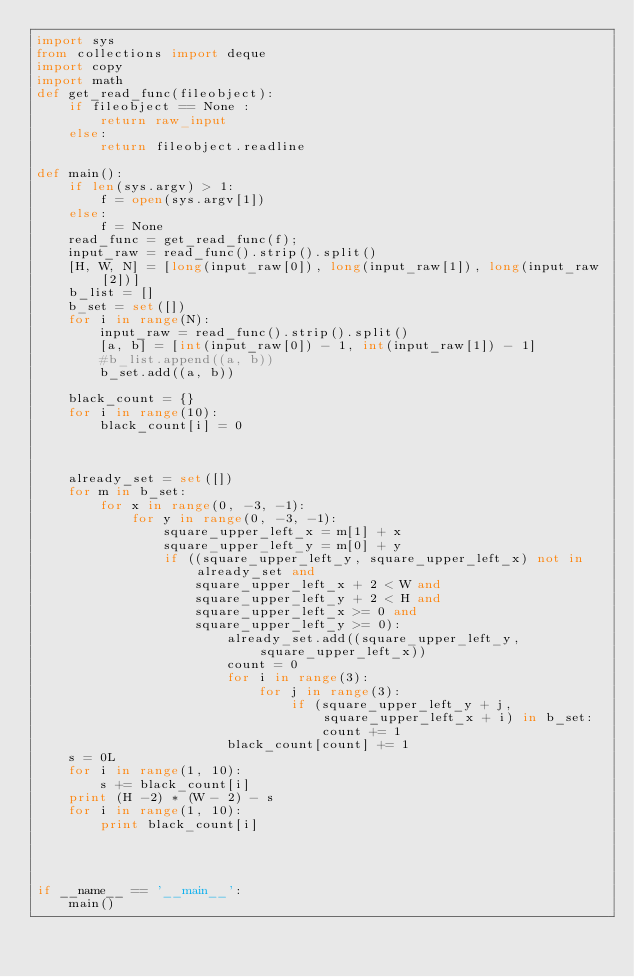<code> <loc_0><loc_0><loc_500><loc_500><_Python_>import sys
from collections import deque
import copy
import math
def get_read_func(fileobject):
    if fileobject == None :
        return raw_input
    else:
        return fileobject.readline

def main():
    if len(sys.argv) > 1:
        f = open(sys.argv[1])
    else:
        f = None
    read_func = get_read_func(f);
    input_raw = read_func().strip().split()
    [H, W, N] = [long(input_raw[0]), long(input_raw[1]), long(input_raw[2])]
    b_list = []
    b_set = set([])
    for i in range(N):
        input_raw = read_func().strip().split()
        [a, b] = [int(input_raw[0]) - 1, int(input_raw[1]) - 1]
        #b_list.append((a, b))
        b_set.add((a, b))

    black_count = {}
    for i in range(10):
        black_count[i] = 0



    already_set = set([])
    for m in b_set:
        for x in range(0, -3, -1):
            for y in range(0, -3, -1):
                square_upper_left_x = m[1] + x
                square_upper_left_y = m[0] + y
                if ((square_upper_left_y, square_upper_left_x) not in already_set and
                    square_upper_left_x + 2 < W and
                    square_upper_left_y + 2 < H and
                    square_upper_left_x >= 0 and
                    square_upper_left_y >= 0):
                        already_set.add((square_upper_left_y, square_upper_left_x))
                        count = 0
                        for i in range(3):
                            for j in range(3):
                                if (square_upper_left_y + j, square_upper_left_x + i) in b_set:
                                    count += 1
                        black_count[count] += 1
    s = 0L
    for i in range(1, 10):
        s += black_count[i]
    print (H -2) * (W - 2) - s
    for i in range(1, 10):
        print black_count[i]




if __name__ == '__main__':
    main()
</code> 